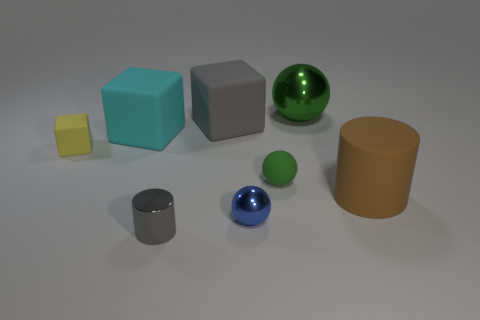There is a brown matte cylinder behind the shiny cylinder; is it the same size as the green thing that is to the left of the green metallic thing?
Make the answer very short. No. There is a ball in front of the large rubber thing that is in front of the green sphere to the left of the big green thing; what is its color?
Make the answer very short. Blue. Is there another small yellow matte object of the same shape as the small yellow object?
Make the answer very short. No. Are there more yellow rubber objects that are to the left of the gray rubber thing than matte balls?
Offer a very short reply. No. What number of rubber things are small yellow cubes or small balls?
Provide a succinct answer. 2. What size is the object that is in front of the large green thing and right of the small green matte ball?
Provide a succinct answer. Large. There is a metal object that is behind the large gray block; are there any large green metal spheres that are behind it?
Provide a short and direct response. No. There is a small gray shiny cylinder; how many large green metallic things are behind it?
Your response must be concise. 1. There is another thing that is the same shape as the large brown matte thing; what is its color?
Provide a succinct answer. Gray. Is the material of the big block that is to the left of the small cylinder the same as the tiny cylinder that is on the left side of the gray matte thing?
Ensure brevity in your answer.  No. 